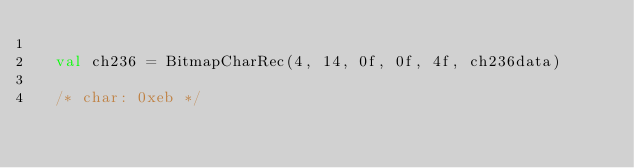Convert code to text. <code><loc_0><loc_0><loc_500><loc_500><_Kotlin_>	
	val ch236 = BitmapCharRec(4, 14, 0f, 0f, 4f, ch236data)
	
	/* char: 0xeb */
	</code> 